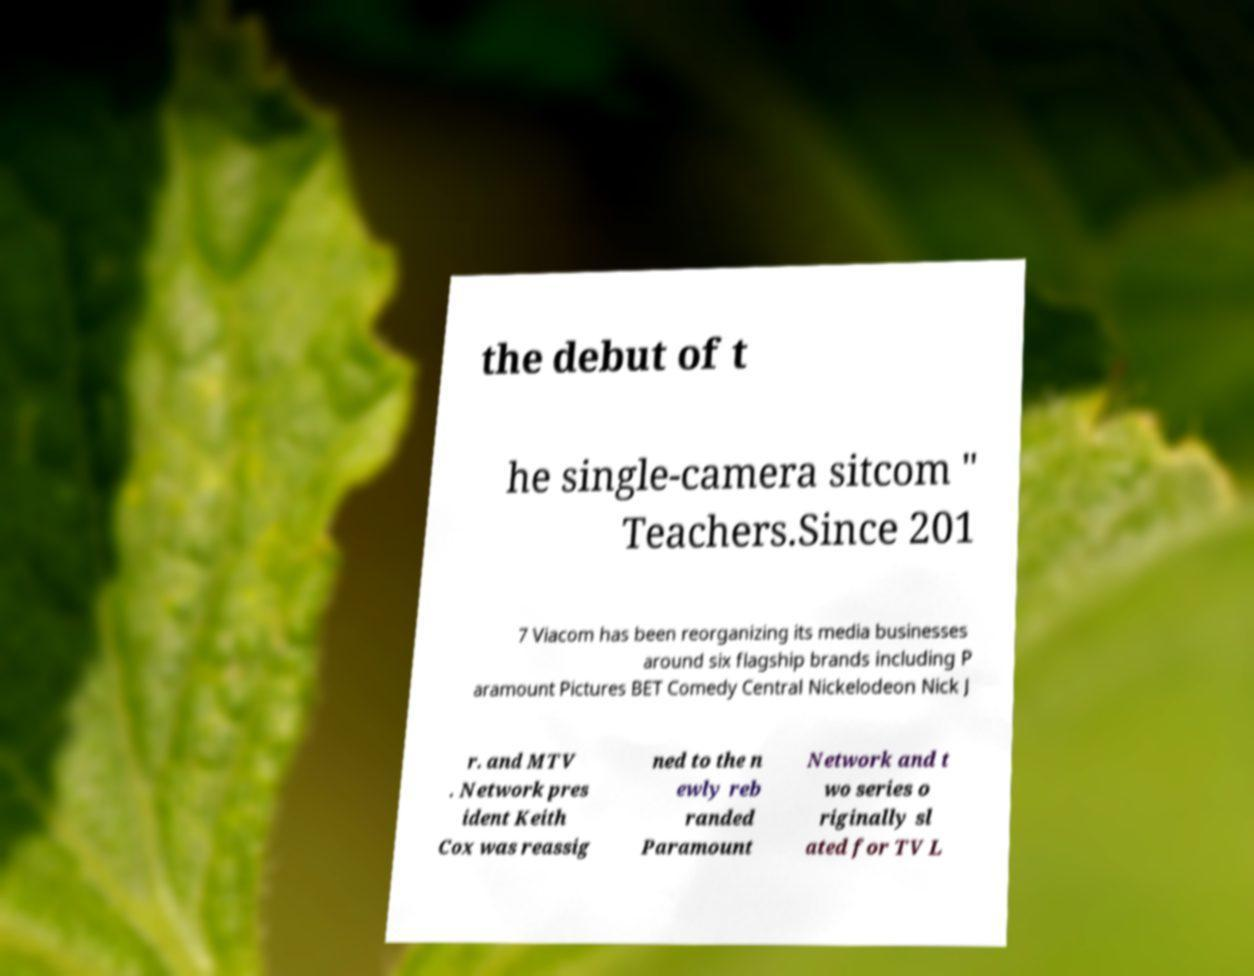Could you extract and type out the text from this image? the debut of t he single-camera sitcom " Teachers.Since 201 7 Viacom has been reorganizing its media businesses around six flagship brands including P aramount Pictures BET Comedy Central Nickelodeon Nick J r. and MTV . Network pres ident Keith Cox was reassig ned to the n ewly reb randed Paramount Network and t wo series o riginally sl ated for TV L 